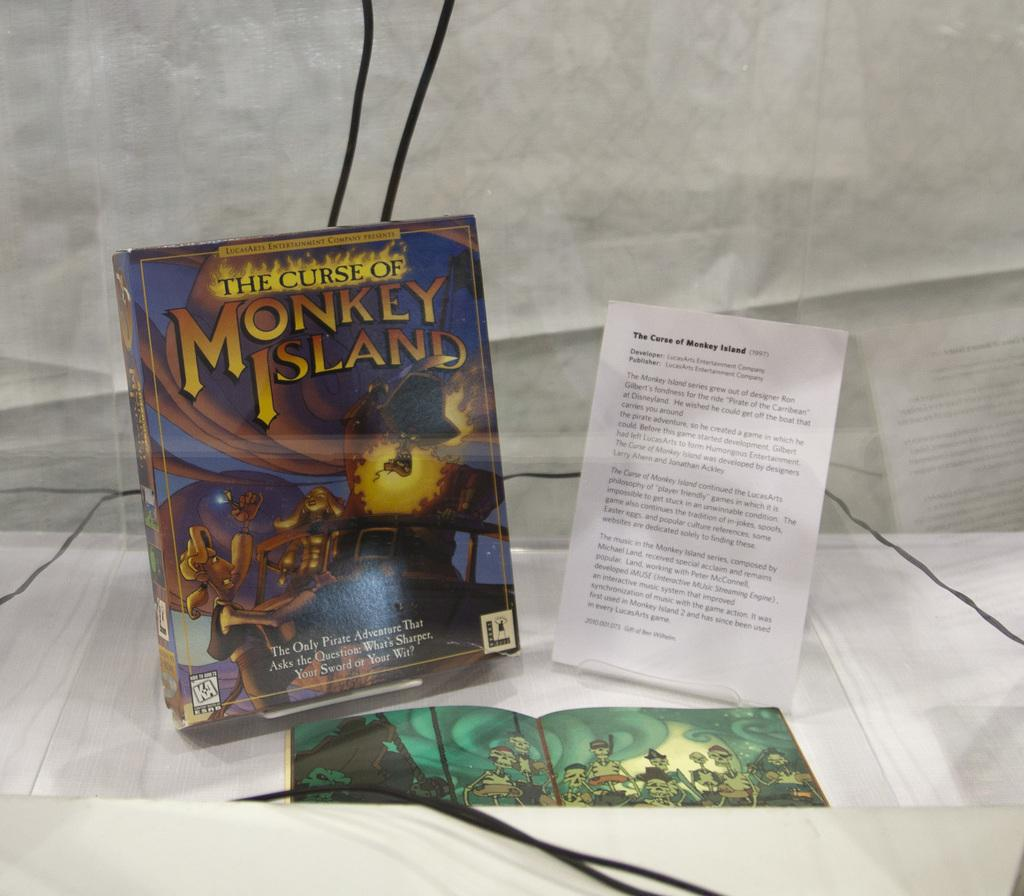<image>
Share a concise interpretation of the image provided. A display with a box that says The Curse of Monkey Island. 